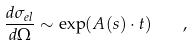Convert formula to latex. <formula><loc_0><loc_0><loc_500><loc_500>\frac { d \sigma _ { e l } } { d \Omega } \sim \exp ( A ( s ) \cdot t ) \quad ,</formula> 